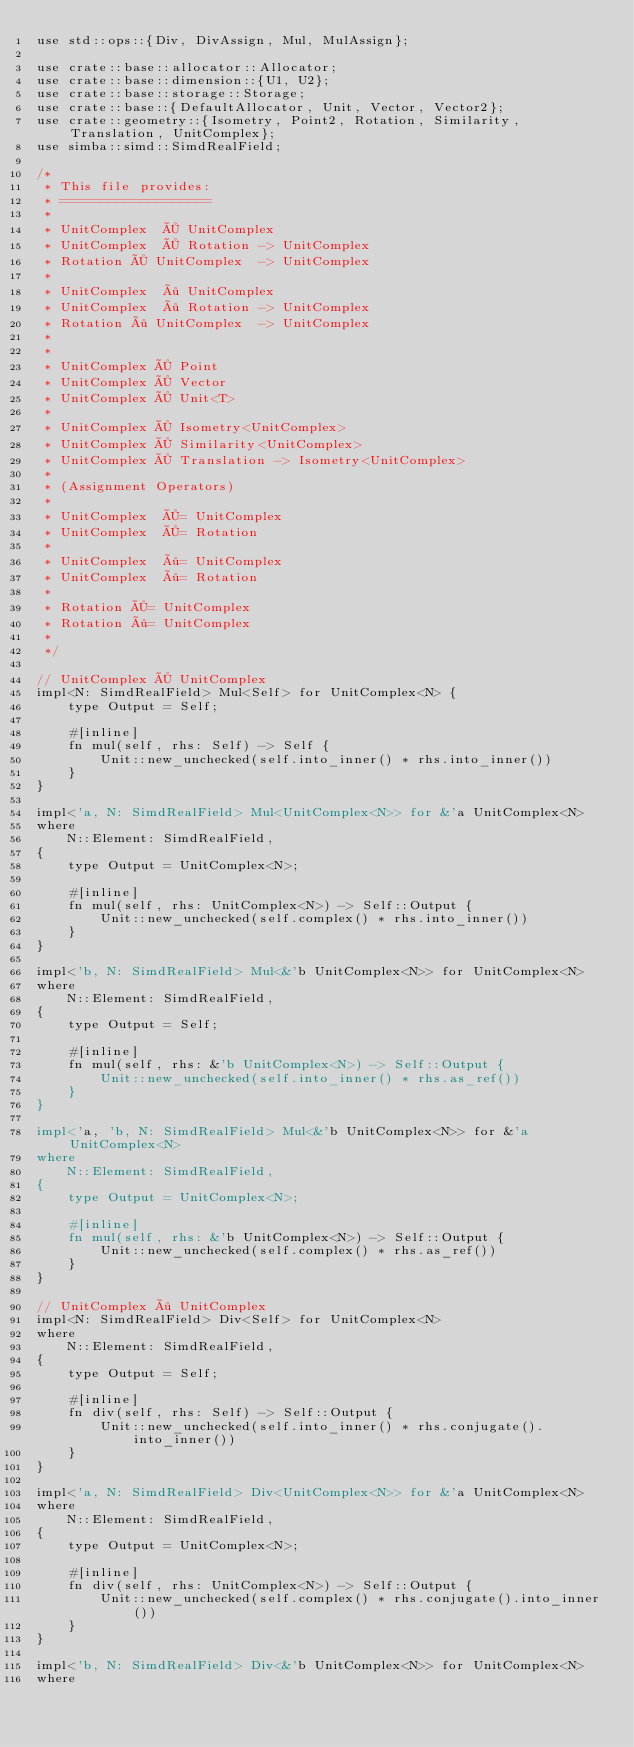Convert code to text. <code><loc_0><loc_0><loc_500><loc_500><_Rust_>use std::ops::{Div, DivAssign, Mul, MulAssign};

use crate::base::allocator::Allocator;
use crate::base::dimension::{U1, U2};
use crate::base::storage::Storage;
use crate::base::{DefaultAllocator, Unit, Vector, Vector2};
use crate::geometry::{Isometry, Point2, Rotation, Similarity, Translation, UnitComplex};
use simba::simd::SimdRealField;

/*
 * This file provides:
 * ===================
 *
 * UnitComplex  × UnitComplex
 * UnitComplex  × Rotation -> UnitComplex
 * Rotation × UnitComplex  -> UnitComplex
 *
 * UnitComplex  ÷ UnitComplex
 * UnitComplex  ÷ Rotation -> UnitComplex
 * Rotation ÷ UnitComplex  -> UnitComplex
 *
 *
 * UnitComplex × Point
 * UnitComplex × Vector
 * UnitComplex × Unit<T>
 *
 * UnitComplex × Isometry<UnitComplex>
 * UnitComplex × Similarity<UnitComplex>
 * UnitComplex × Translation -> Isometry<UnitComplex>
 *
 * (Assignment Operators)
 *
 * UnitComplex  ×= UnitComplex
 * UnitComplex  ×= Rotation
 *
 * UnitComplex  ÷= UnitComplex
 * UnitComplex  ÷= Rotation
 *
 * Rotation ×= UnitComplex
 * Rotation ÷= UnitComplex
 *
 */

// UnitComplex × UnitComplex
impl<N: SimdRealField> Mul<Self> for UnitComplex<N> {
    type Output = Self;

    #[inline]
    fn mul(self, rhs: Self) -> Self {
        Unit::new_unchecked(self.into_inner() * rhs.into_inner())
    }
}

impl<'a, N: SimdRealField> Mul<UnitComplex<N>> for &'a UnitComplex<N>
where
    N::Element: SimdRealField,
{
    type Output = UnitComplex<N>;

    #[inline]
    fn mul(self, rhs: UnitComplex<N>) -> Self::Output {
        Unit::new_unchecked(self.complex() * rhs.into_inner())
    }
}

impl<'b, N: SimdRealField> Mul<&'b UnitComplex<N>> for UnitComplex<N>
where
    N::Element: SimdRealField,
{
    type Output = Self;

    #[inline]
    fn mul(self, rhs: &'b UnitComplex<N>) -> Self::Output {
        Unit::new_unchecked(self.into_inner() * rhs.as_ref())
    }
}

impl<'a, 'b, N: SimdRealField> Mul<&'b UnitComplex<N>> for &'a UnitComplex<N>
where
    N::Element: SimdRealField,
{
    type Output = UnitComplex<N>;

    #[inline]
    fn mul(self, rhs: &'b UnitComplex<N>) -> Self::Output {
        Unit::new_unchecked(self.complex() * rhs.as_ref())
    }
}

// UnitComplex ÷ UnitComplex
impl<N: SimdRealField> Div<Self> for UnitComplex<N>
where
    N::Element: SimdRealField,
{
    type Output = Self;

    #[inline]
    fn div(self, rhs: Self) -> Self::Output {
        Unit::new_unchecked(self.into_inner() * rhs.conjugate().into_inner())
    }
}

impl<'a, N: SimdRealField> Div<UnitComplex<N>> for &'a UnitComplex<N>
where
    N::Element: SimdRealField,
{
    type Output = UnitComplex<N>;

    #[inline]
    fn div(self, rhs: UnitComplex<N>) -> Self::Output {
        Unit::new_unchecked(self.complex() * rhs.conjugate().into_inner())
    }
}

impl<'b, N: SimdRealField> Div<&'b UnitComplex<N>> for UnitComplex<N>
where</code> 